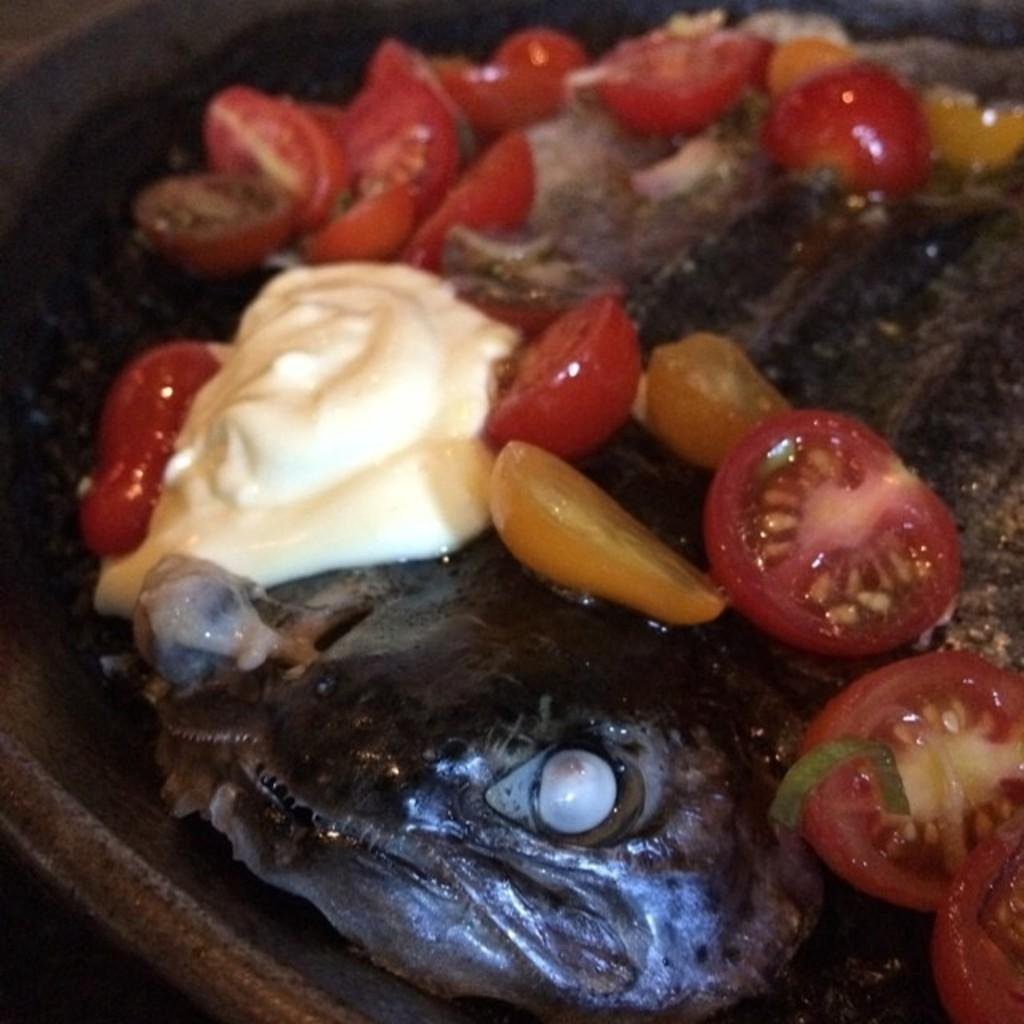What is present in the bowl in the image? There are food items in a bowl in the image. What type of structure can be seen carrying the food items in the image? There is no structure carrying the food items in the image; they are in a bowl. What type of paste is used to prepare the food items in the image? There is no information about the preparation of the food items or the use of paste in the image. 